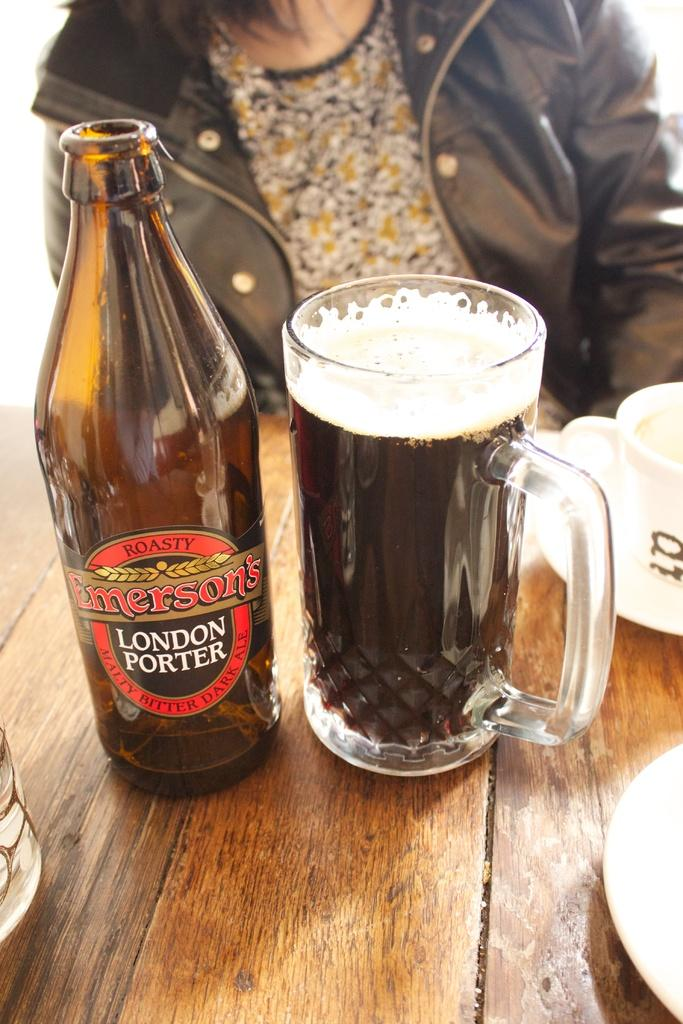<image>
Summarize the visual content of the image. A bottle of Emerson's London Porter next to a glass of beer. 